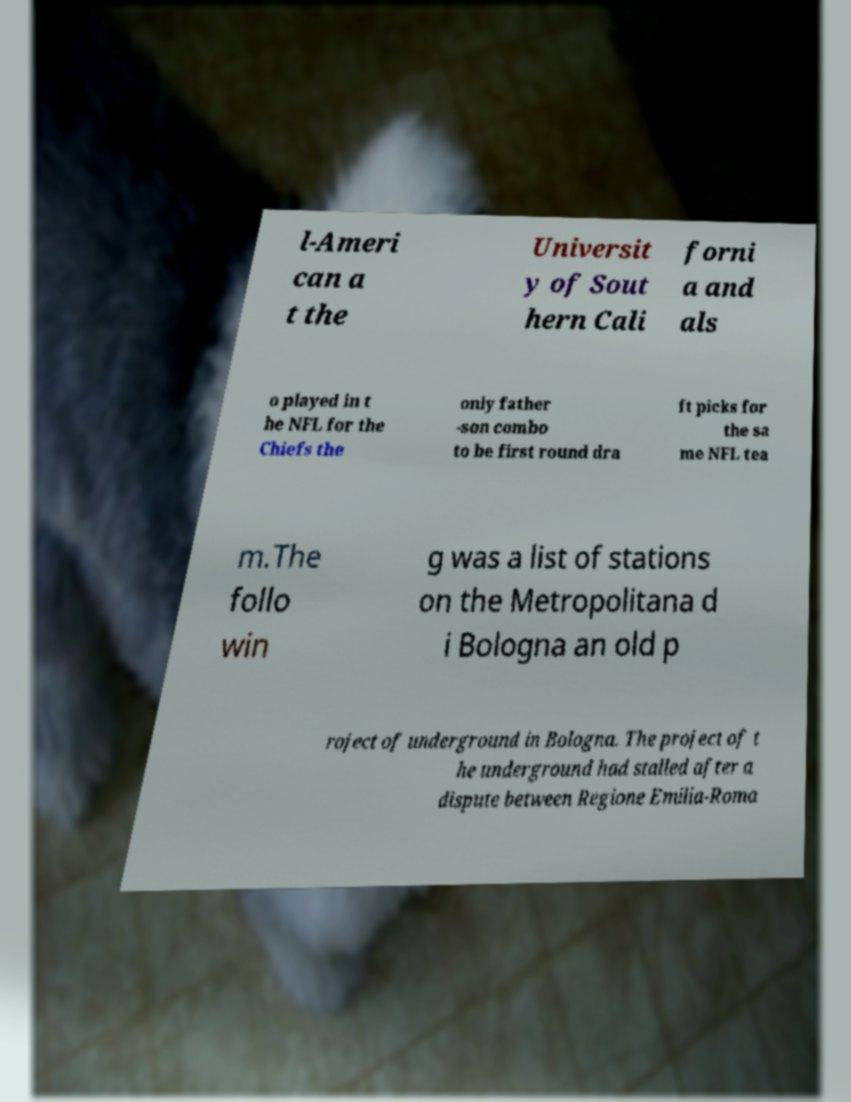Could you assist in decoding the text presented in this image and type it out clearly? l-Ameri can a t the Universit y of Sout hern Cali forni a and als o played in t he NFL for the Chiefs the only father -son combo to be first round dra ft picks for the sa me NFL tea m.The follo win g was a list of stations on the Metropolitana d i Bologna an old p roject of underground in Bologna. The project of t he underground had stalled after a dispute between Regione Emilia-Roma 